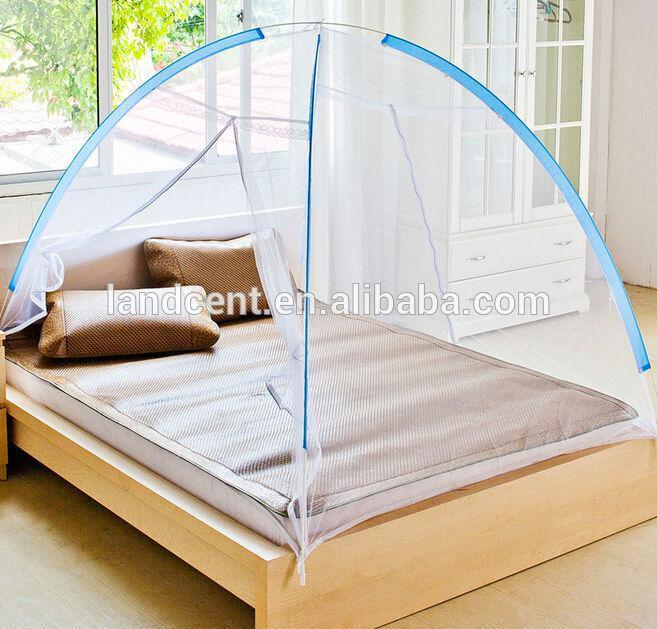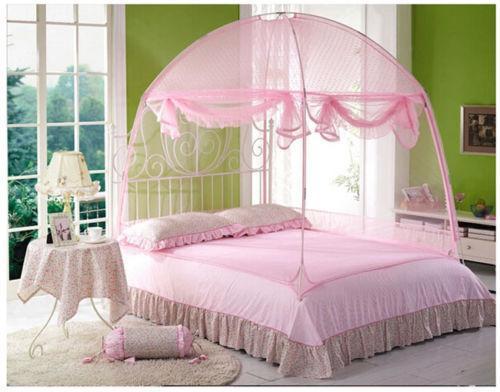The first image is the image on the left, the second image is the image on the right. Considering the images on both sides, is "A bed has a blue-trimmed canopy with a band of patterned fabric around the base." valid? Answer yes or no. No. 